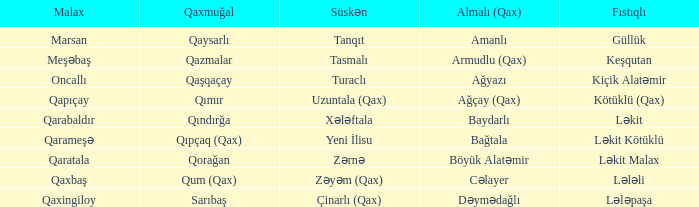What is the Qaxmuğal village with a Fistiqli village keşqutan? Qazmalar. 